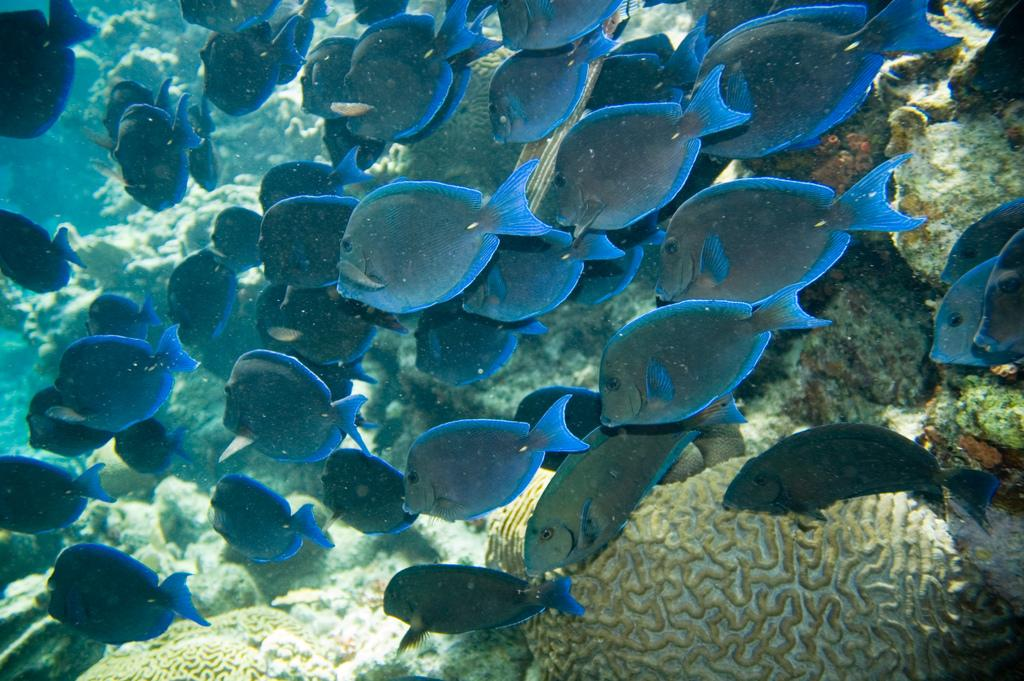What type of animals are in the image? There are fishes in the image. What is the specific type of fish in the image? The fishes are called Atlantic blue tang. Where are the fishes located in the image? The fishes are underwater. What else can be seen in the water in the image? There are water plants in the image. What type of thing can be seen flying with a wing in the image? There is no thing with a wing present in the image; it features underwater fishes and water plants. 